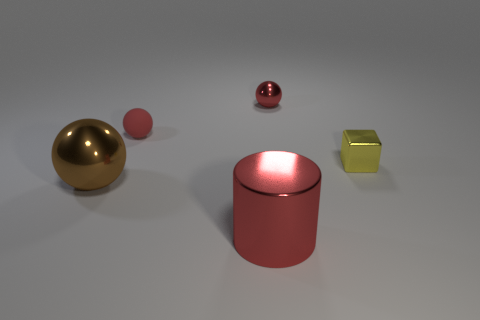Is there anything that indicates the scale or potential size of these objects? Without any familiar objects or references points for scale, it's challenging to determine the exact size of these objects. Their proportions in relation to each other suggest they could range from miniature models to sizable furniture-like dimensions. 